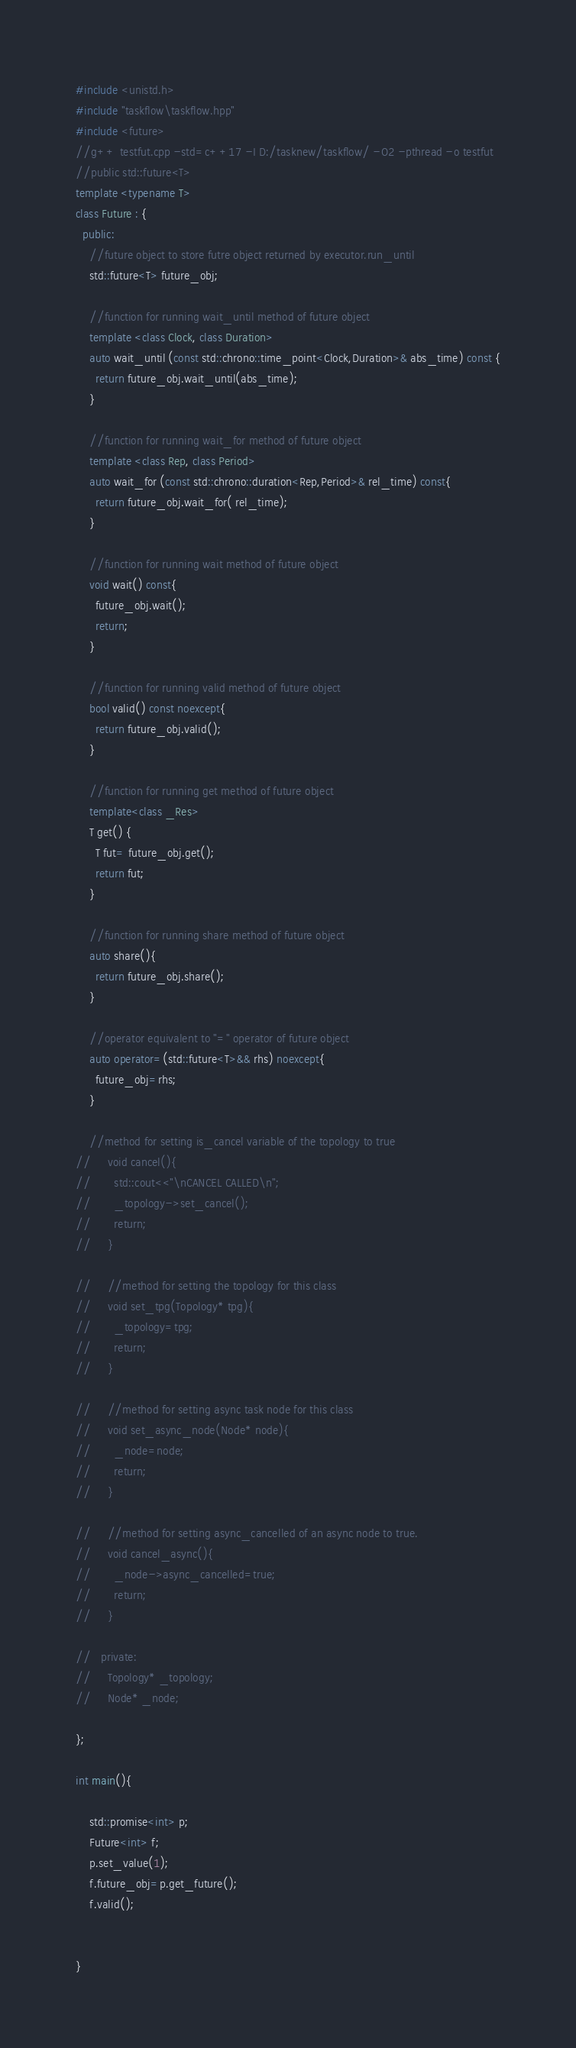Convert code to text. <code><loc_0><loc_0><loc_500><loc_500><_C++_>
#include <unistd.h>
#include "taskflow\taskflow.hpp"
#include <future>
//g++ testfut.cpp -std=c++17 -I D:/tasknew/taskflow/ -O2 -pthread -o testfut
//public std::future<T> 
template <typename T>
class Future : {
  public:
    //future object to store futre object returned by executor.run_until
    std::future<T> future_obj;

    //function for running wait_until method of future object
    template <class Clock, class Duration>
    auto wait_until (const std::chrono::time_point<Clock,Duration>& abs_time) const {
      return future_obj.wait_until(abs_time);
    }

    //function for running wait_for method of future object
    template <class Rep, class Period>
    auto wait_for (const std::chrono::duration<Rep,Period>& rel_time) const{
      return future_obj.wait_for( rel_time);
    }
    
    //function for running wait method of future object
    void wait() const{
      future_obj.wait();
      return;
    }

    //function for running valid method of future object
    bool valid() const noexcept{
      return future_obj.valid();
    }

    //function for running get method of future object
    template<class _Res>
    T get() {
      T fut= future_obj.get();
      return fut;
    }

    //function for running share method of future object
    auto share(){
      return future_obj.share();
    }

    //operator equivalent to "=" operator of future object
    auto operator=(std::future<T>&& rhs) noexcept{
      future_obj=rhs;
    }

    //method for setting is_cancel variable of the topology to true
//     void cancel(){
//       std::cout<<"\nCANCEL CALLED\n";
//       _topology->set_cancel();
//       return;
//     }

//     //method for setting the topology for this class
//     void set_tpg(Topology* tpg){
//       _topology=tpg;
//       return;
//     }

//     //method for setting async task node for this class
//     void set_async_node(Node* node){
//       _node=node;
//       return;
//     }

//     //method for setting async_cancelled of an async node to true.
//     void cancel_async(){
//       _node->async_cancelled=true;
//       return;
//     }

//   private:
//     Topology* _topology;
//     Node* _node;

};

int main(){

    std::promise<int> p;
    Future<int> f;
    p.set_value(1);
    f.future_obj=p.get_future();
    f.valid();


}</code> 